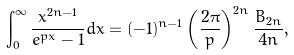Convert formula to latex. <formula><loc_0><loc_0><loc_500><loc_500>\int _ { 0 } ^ { \infty } \frac { x ^ { 2 n - 1 } } { e ^ { p x } - 1 } d x = ( - 1 ) ^ { n - 1 } \left ( \frac { 2 \pi } { p } \right ) ^ { 2 n } \frac { B _ { 2 n } } { 4 n } ,</formula> 